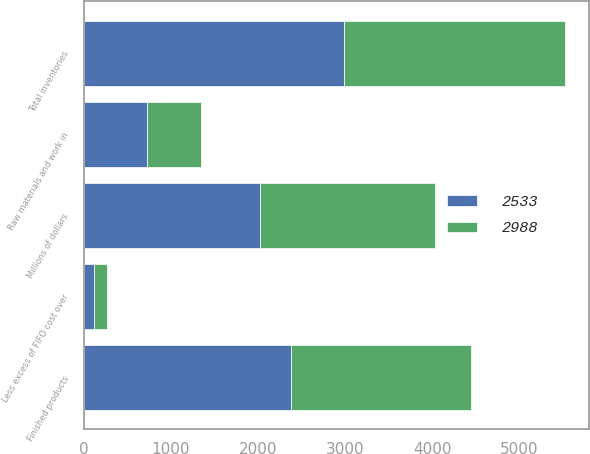Convert chart. <chart><loc_0><loc_0><loc_500><loc_500><stacked_bar_chart><ecel><fcel>Millions of dollars<fcel>Finished products<fcel>Raw materials and work in<fcel>Less excess of FIFO cost over<fcel>Total inventories<nl><fcel>2988<fcel>2018<fcel>2076<fcel>617<fcel>160<fcel>2533<nl><fcel>2533<fcel>2017<fcel>2374<fcel>725<fcel>111<fcel>2988<nl></chart> 